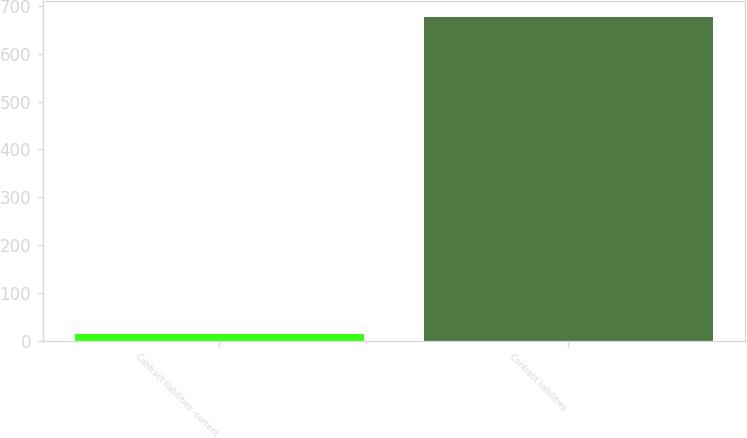<chart> <loc_0><loc_0><loc_500><loc_500><bar_chart><fcel>Contract liabilities -current<fcel>Contract liabilities<nl><fcel>13.1<fcel>676.4<nl></chart> 